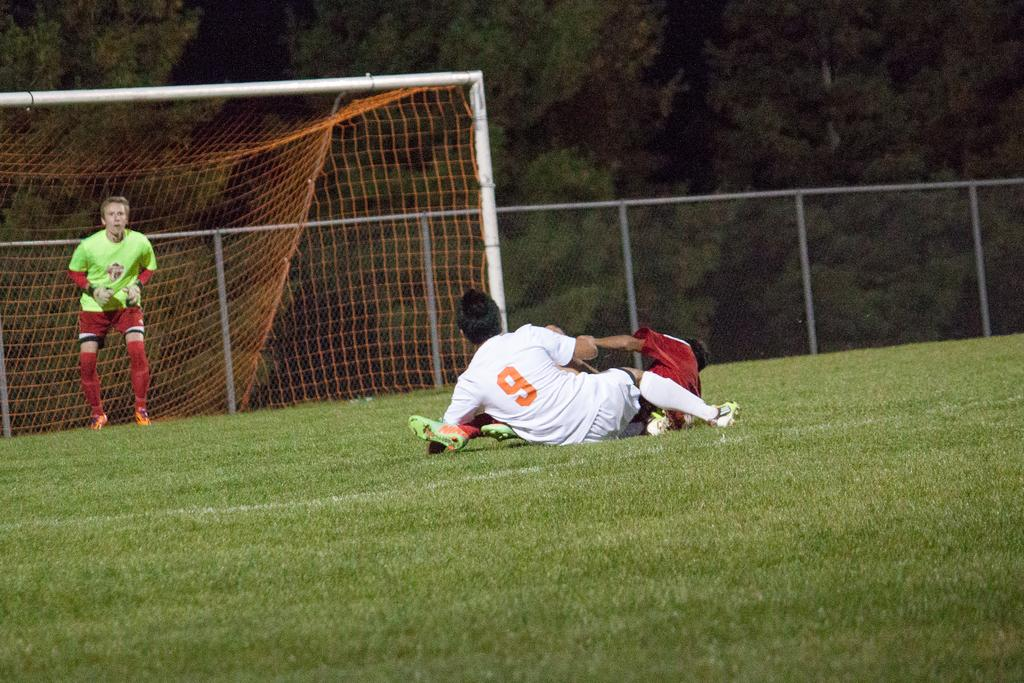<image>
Render a clear and concise summary of the photo. Soccer player with a number 9 on his shirt fell on the ground. 